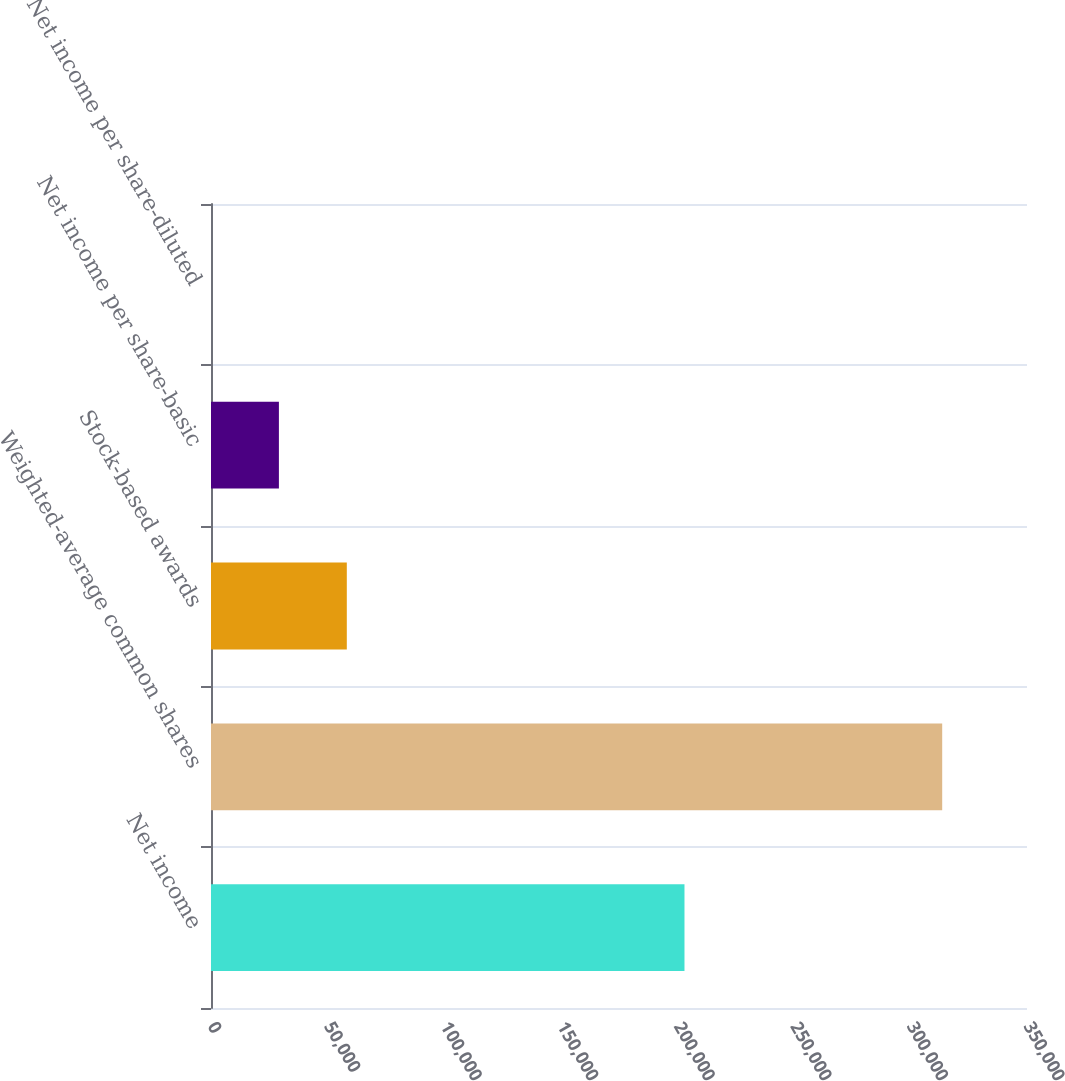Convert chart. <chart><loc_0><loc_0><loc_500><loc_500><bar_chart><fcel>Net income<fcel>Weighted-average common shares<fcel>Stock-based awards<fcel>Net income per share-basic<fcel>Net income per share-diluted<nl><fcel>203086<fcel>313628<fcel>58251.8<fcel>29126.2<fcel>0.7<nl></chart> 